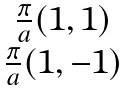Convert formula to latex. <formula><loc_0><loc_0><loc_500><loc_500>\begin{matrix} \frac { \pi } { a } ( 1 , 1 ) \\ \frac { \pi } { a } ( 1 , - 1 ) \end{matrix}</formula> 